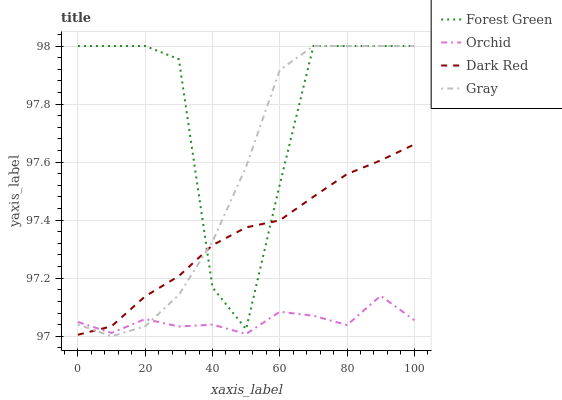Does Gray have the minimum area under the curve?
Answer yes or no. No. Does Gray have the maximum area under the curve?
Answer yes or no. No. Is Gray the smoothest?
Answer yes or no. No. Is Gray the roughest?
Answer yes or no. No. Does Forest Green have the lowest value?
Answer yes or no. No. Does Orchid have the highest value?
Answer yes or no. No. Is Orchid less than Forest Green?
Answer yes or no. Yes. Is Forest Green greater than Orchid?
Answer yes or no. Yes. Does Orchid intersect Forest Green?
Answer yes or no. No. 